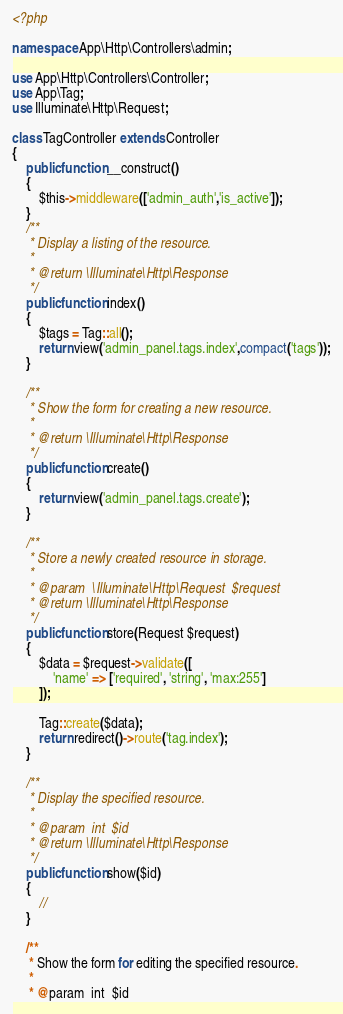<code> <loc_0><loc_0><loc_500><loc_500><_PHP_><?php

namespace App\Http\Controllers\admin;

use App\Http\Controllers\Controller;
use App\Tag;
use Illuminate\Http\Request;

class TagController extends Controller
{
    public function __construct()
    {
        $this->middleware(['admin_auth','is_active']);
    }
    /**
     * Display a listing of the resource.
     *
     * @return \Illuminate\Http\Response
     */
    public function index()
    {
        $tags = Tag::all();
        return view('admin_panel.tags.index',compact('tags'));
    }

    /**
     * Show the form for creating a new resource.
     *
     * @return \Illuminate\Http\Response
     */
    public function create()
    {
        return view('admin_panel.tags.create');
    }

    /**
     * Store a newly created resource in storage.
     *
     * @param  \Illuminate\Http\Request  $request
     * @return \Illuminate\Http\Response
     */
    public function store(Request $request)
    {
        $data = $request->validate([
            'name' => ['required', 'string', 'max:255']
        ]);

        Tag::create($data);
        return redirect()->route('tag.index');
    }

    /**
     * Display the specified resource.
     *
     * @param  int  $id
     * @return \Illuminate\Http\Response
     */
    public function show($id)
    {
        //
    }

    /**
     * Show the form for editing the specified resource.
     *
     * @param  int  $id</code> 